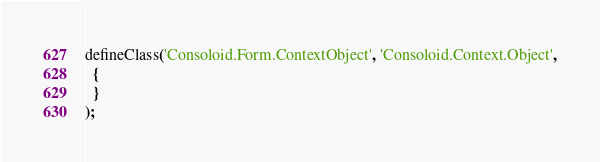Convert code to text. <code><loc_0><loc_0><loc_500><loc_500><_JavaScript_>defineClass('Consoloid.Form.ContextObject', 'Consoloid.Context.Object',
  {
  }
);</code> 